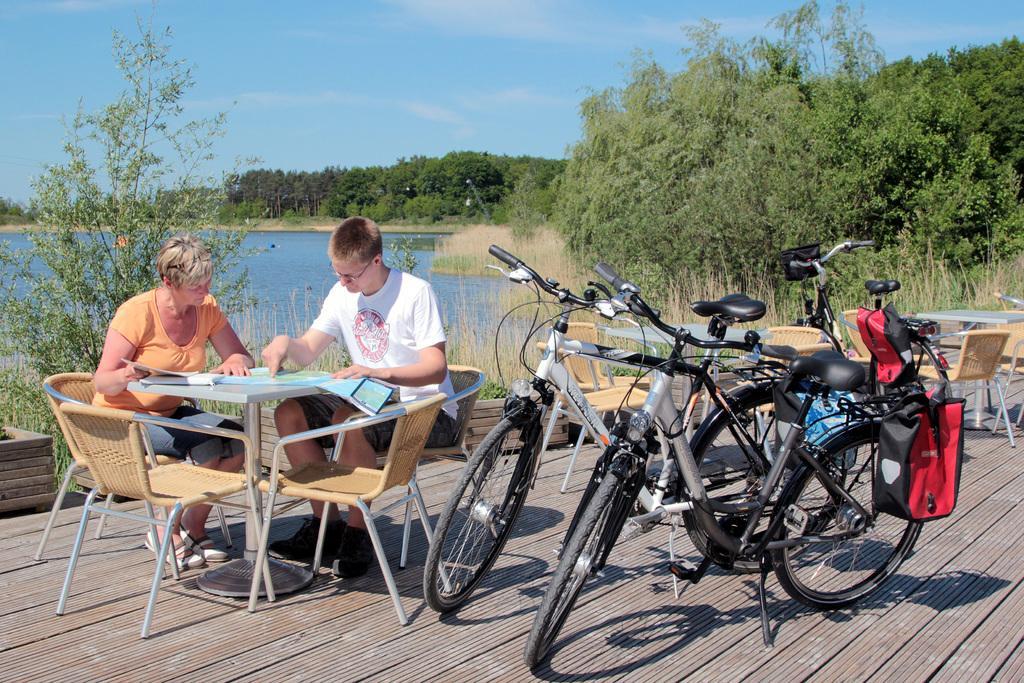Could you give a brief overview of what you see in this image? This picture is taken at the beach. In the center there are two bicycles. At the right side there is one bicycle and empty chairs. Two persons are sitting at the left side on chair discussing something. In the background there is a sky, cloud, some trees, water, dry grass. 